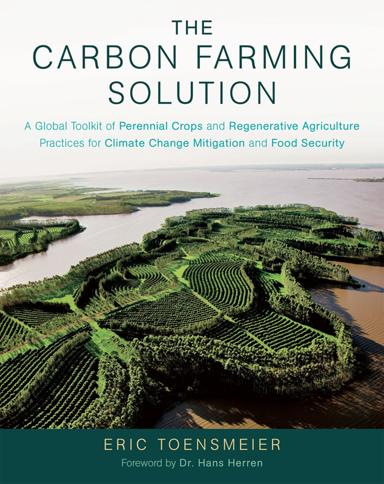Who wrote the foreword for the book? The foreword of "The Carbon Farming Solution" was penned by Dr. Hans Herren, a renowned expert in sustainable agriculture, highlighting the book's emphasis on practical and environmentally friendly farming techniques. 